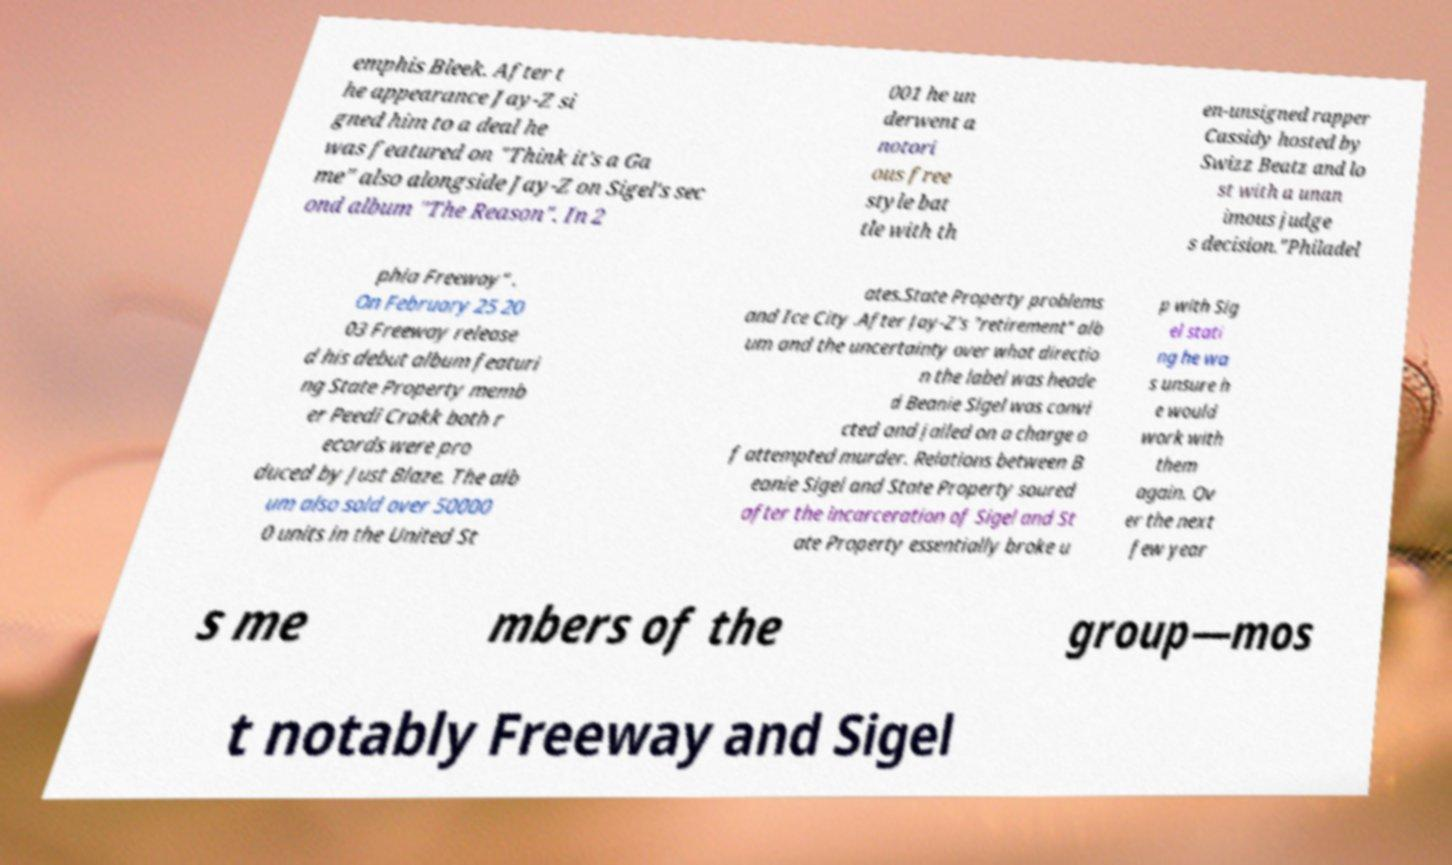What messages or text are displayed in this image? I need them in a readable, typed format. emphis Bleek. After t he appearance Jay-Z si gned him to a deal he was featured on "Think it's a Ga me" also alongside Jay-Z on Sigel's sec ond album "The Reason". In 2 001 he un derwent a notori ous free style bat tle with th en-unsigned rapper Cassidy hosted by Swizz Beatz and lo st with a unan imous judge s decision."Philadel phia Freeway" . On February 25 20 03 Freeway release d his debut album featuri ng State Property memb er Peedi Crakk both r ecords were pro duced by Just Blaze. The alb um also sold over 50000 0 units in the United St ates.State Property problems and Ice City .After Jay-Z's "retirement" alb um and the uncertainty over what directio n the label was heade d Beanie Sigel was convi cted and jailed on a charge o f attempted murder. Relations between B eanie Sigel and State Property soured after the incarceration of Sigel and St ate Property essentially broke u p with Sig el stati ng he wa s unsure h e would work with them again. Ov er the next few year s me mbers of the group—mos t notably Freeway and Sigel 